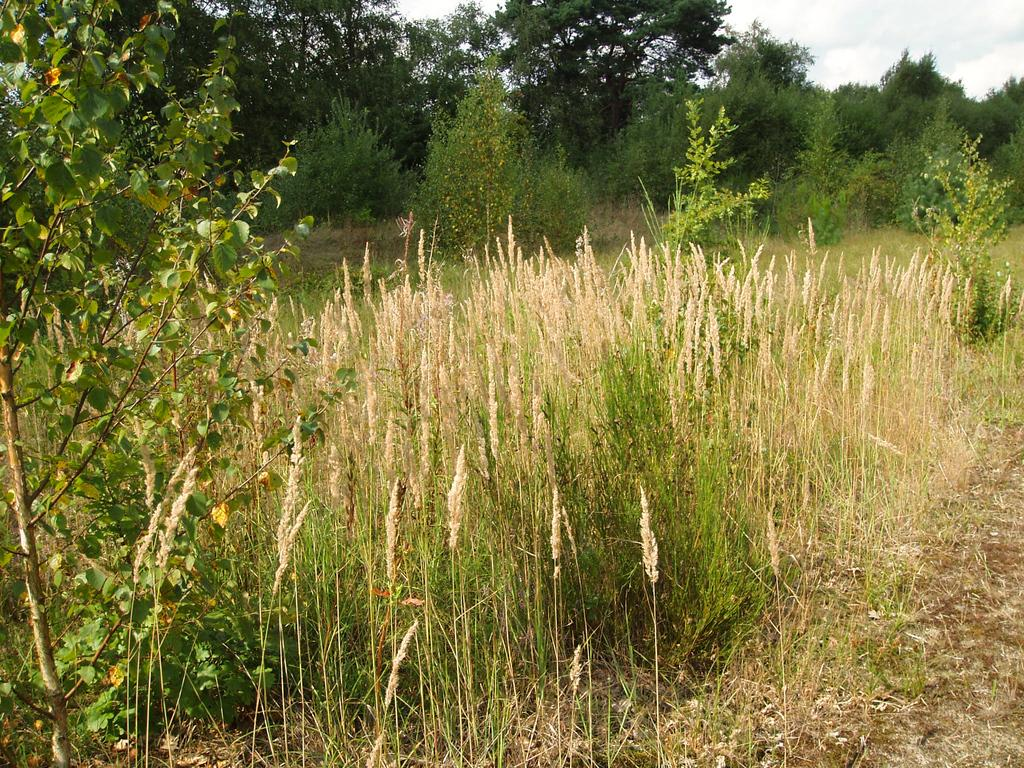What type of vegetation can be seen in the image? There is grass, plants, and trees in the image. What part of the natural environment is visible in the image? The sky is visible in the background of the image. What is the chance of finding a beetle in the image? There is no beetle present in the image, so it is not possible to determine the chance of finding one. 